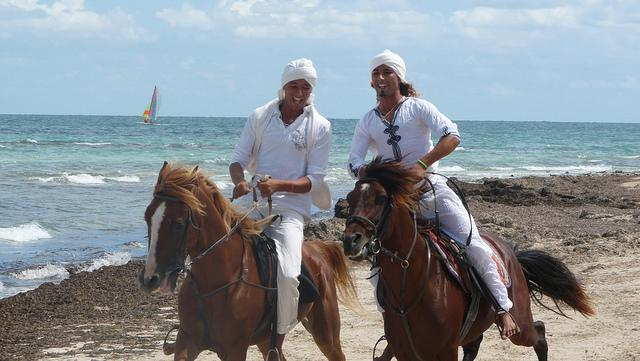Why are they so close together?

Choices:
A) to talk
B) need directions
C) afraid alone
D) to fight to talk 